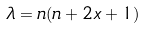<formula> <loc_0><loc_0><loc_500><loc_500>\lambda = n ( n + 2 x + 1 )</formula> 